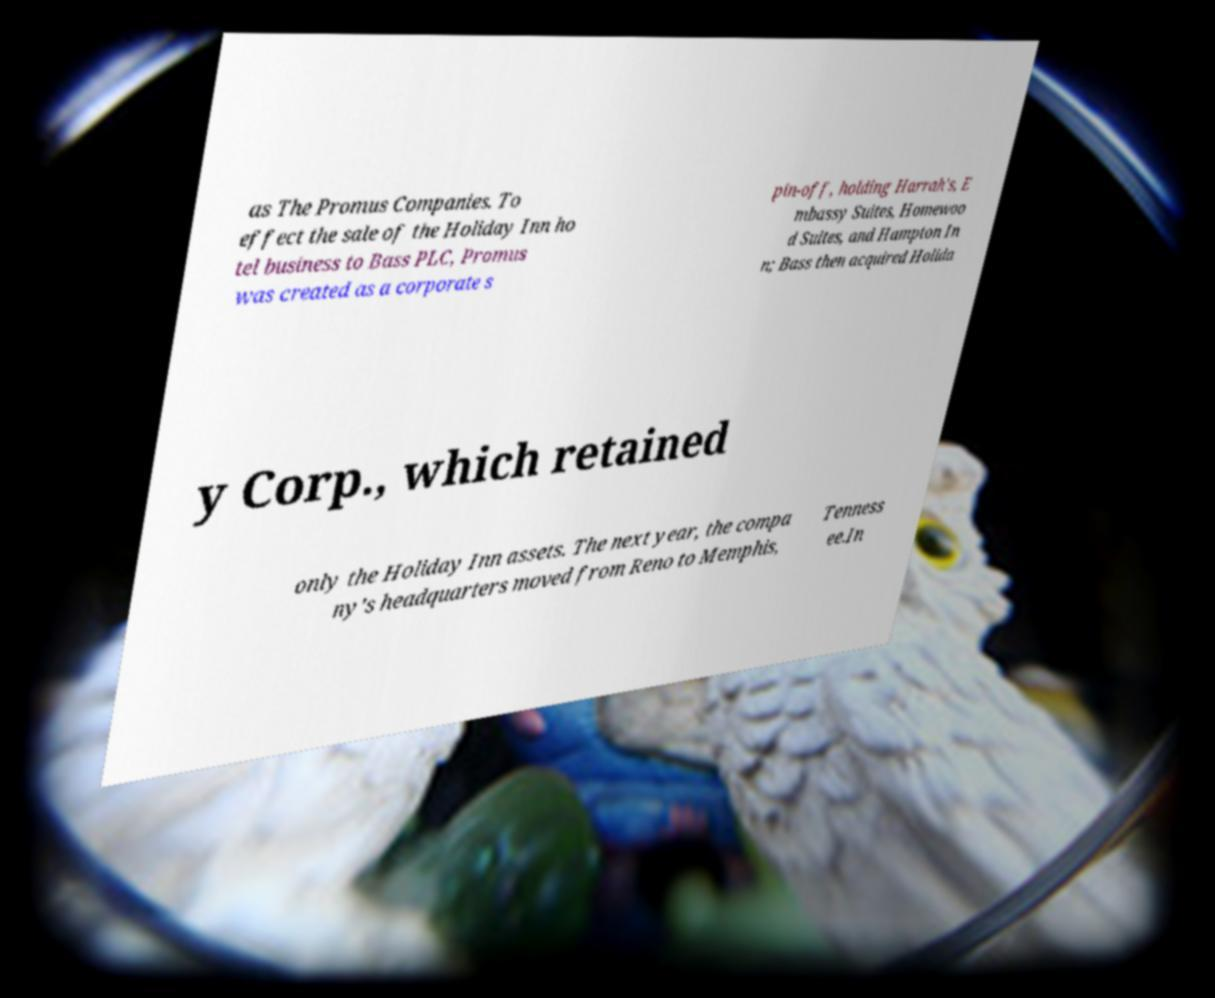Can you accurately transcribe the text from the provided image for me? as The Promus Companies. To effect the sale of the Holiday Inn ho tel business to Bass PLC, Promus was created as a corporate s pin-off, holding Harrah's, E mbassy Suites, Homewoo d Suites, and Hampton In n; Bass then acquired Holida y Corp., which retained only the Holiday Inn assets. The next year, the compa ny's headquarters moved from Reno to Memphis, Tenness ee.In 